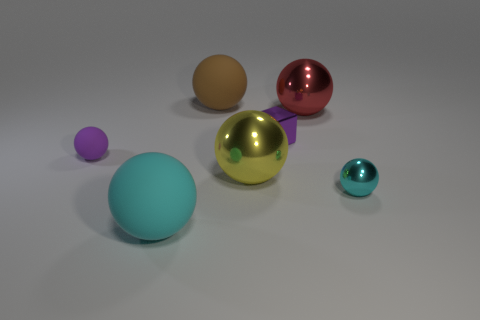How many things are either large objects that are in front of the small cyan object or small matte spheres?
Offer a very short reply. 2. What size is the cyan sphere on the left side of the small purple shiny block that is on the left side of the small sphere that is to the right of the large brown matte thing?
Ensure brevity in your answer.  Large. There is a sphere that is the same color as the small block; what material is it?
Ensure brevity in your answer.  Rubber. Are there any other things that have the same shape as the tiny purple metal thing?
Offer a very short reply. No. There is a rubber ball that is left of the cyan thing on the left side of the yellow metallic thing; what is its size?
Offer a very short reply. Small. How many big things are either yellow metallic objects or red metallic spheres?
Your response must be concise. 2. Are there fewer cyan metal things than small blue metal things?
Give a very brief answer. No. Is there anything else that is the same size as the cyan shiny sphere?
Give a very brief answer. Yes. Is the color of the shiny block the same as the small rubber ball?
Your answer should be very brief. Yes. Are there more big things than tiny blue spheres?
Provide a succinct answer. Yes. 